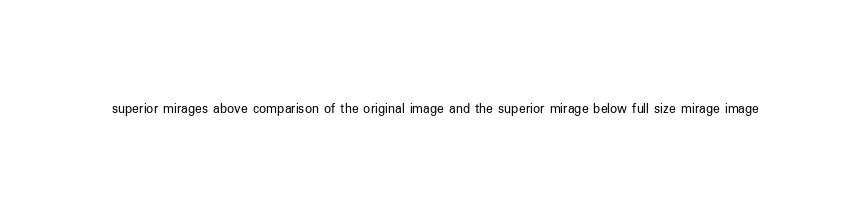Convert code to text. <code><loc_0><loc_0><loc_500><loc_500><_HTML_>superior mirages above comparison of the original image and the superior mirage below full size mirage image
</code> 